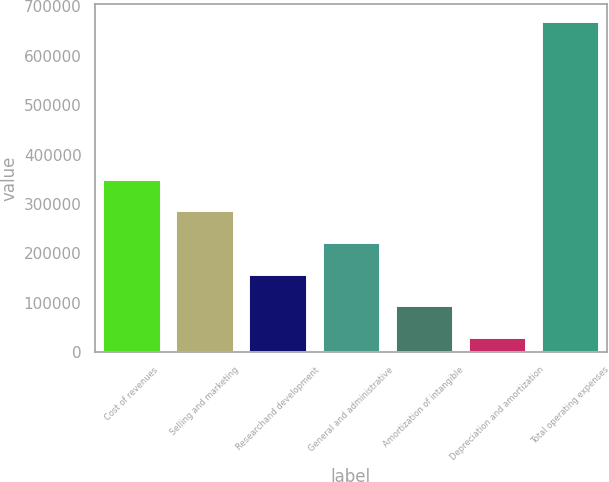Convert chart to OTSL. <chart><loc_0><loc_0><loc_500><loc_500><bar_chart><fcel>Cost of revenues<fcel>Selling and marketing<fcel>Researchand development<fcel>General and administrative<fcel>Amortization of intangible<fcel>Depreciation and amortization<fcel>Total operating expenses<nl><fcel>351002<fcel>286979<fcel>158934<fcel>222957<fcel>94911.6<fcel>30889<fcel>671115<nl></chart> 